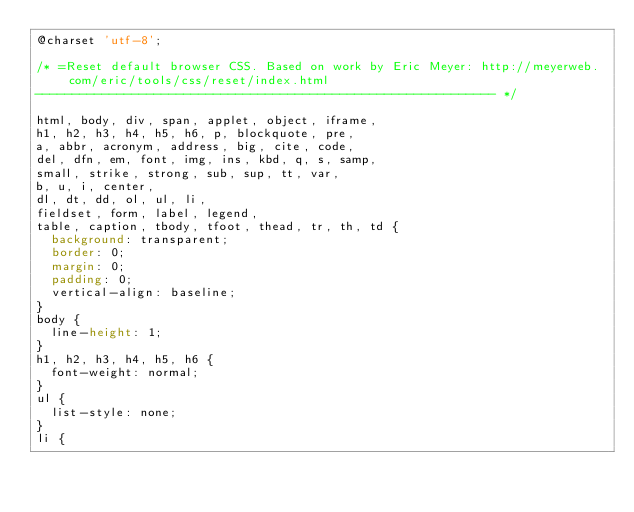<code> <loc_0><loc_0><loc_500><loc_500><_CSS_>@charset 'utf-8';

/* =Reset default browser CSS. Based on work by Eric Meyer: http://meyerweb.com/eric/tools/css/reset/index.html
-------------------------------------------------------------- */

html, body, div, span, applet, object, iframe,
h1, h2, h3, h4, h5, h6, p, blockquote, pre,
a, abbr, acronym, address, big, cite, code,
del, dfn, em, font, img, ins, kbd, q, s, samp,
small, strike, strong, sub, sup, tt, var,
b, u, i, center,
dl, dt, dd, ol, ul, li,
fieldset, form, label, legend,
table, caption, tbody, tfoot, thead, tr, th, td {
	background: transparent;
	border: 0;
	margin: 0;
	padding: 0;
	vertical-align: baseline;
}
body {
	line-height: 1;
}
h1, h2, h3, h4, h5, h6 {
	font-weight: normal;
}
ul {
	list-style: none;
}
li {</code> 